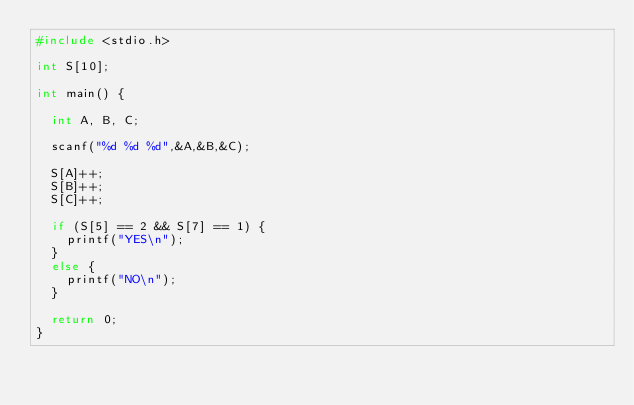Convert code to text. <code><loc_0><loc_0><loc_500><loc_500><_C_>#include <stdio.h>

int S[10];

int main() {

	int A, B, C;

	scanf("%d %d %d",&A,&B,&C);

	S[A]++;
	S[B]++;
	S[C]++;

	if (S[5] == 2 && S[7] == 1) {
		printf("YES\n");
	}
	else {
		printf("NO\n");
	}

	return 0;
}</code> 